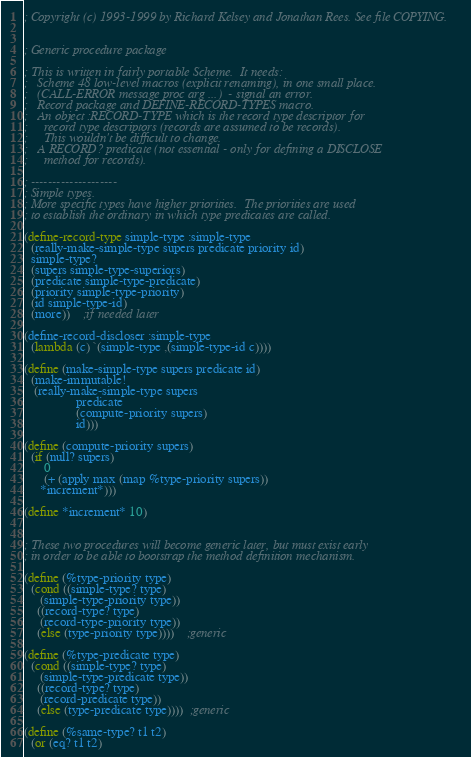Convert code to text. <code><loc_0><loc_0><loc_500><loc_500><_Scheme_>; Copyright (c) 1993-1999 by Richard Kelsey and Jonathan Rees. See file COPYING.


; Generic procedure package

; This is written in fairly portable Scheme.  It needs:
;   Scheme 48 low-level macros (explicit renaming), in one small place.
;   (CALL-ERROR message proc arg ...)  - signal an error.
;   Record package and DEFINE-RECORD-TYPES macro.
;   An object :RECORD-TYPE which is the record type descriptor for
;     record type descriptors (records are assumed to be records).
;     This wouldn't be difficult to change.
;   A RECORD? predicate (not essential - only for defining a DISCLOSE
;     method for records).

; --------------------
; Simple types.
; More specific types have higher priorities.  The priorities are used
; to establish the ordinary in which type predicates are called.

(define-record-type simple-type :simple-type
  (really-make-simple-type supers predicate priority id)
  simple-type?
  (supers simple-type-superiors)
  (predicate simple-type-predicate)
  (priority simple-type-priority)
  (id simple-type-id)
  (more))    ;if needed later

(define-record-discloser :simple-type
  (lambda (c) `(simple-type ,(simple-type-id c))))

(define (make-simple-type supers predicate id)
  (make-immutable!
   (really-make-simple-type supers
			    predicate
			    (compute-priority supers)
			    id)))

(define (compute-priority supers)
  (if (null? supers)
      0
      (+ (apply max (map %type-priority supers))
	 *increment*)))

(define *increment* 10)


; These two procedures will become generic later, but must exist early
; in order to be able to bootstrap the method definition mechanism.

(define (%type-priority type)
  (cond ((simple-type? type)
	 (simple-type-priority type))
	((record-type? type)
	 (record-type-priority type))
	(else (type-priority type))))	;generic

(define (%type-predicate type)
  (cond ((simple-type? type)
	 (simple-type-predicate type))
	((record-type? type)
	 (record-predicate type))
	(else (type-predicate type))))  ;generic

(define (%same-type? t1 t2)
  (or (eq? t1 t2)</code> 